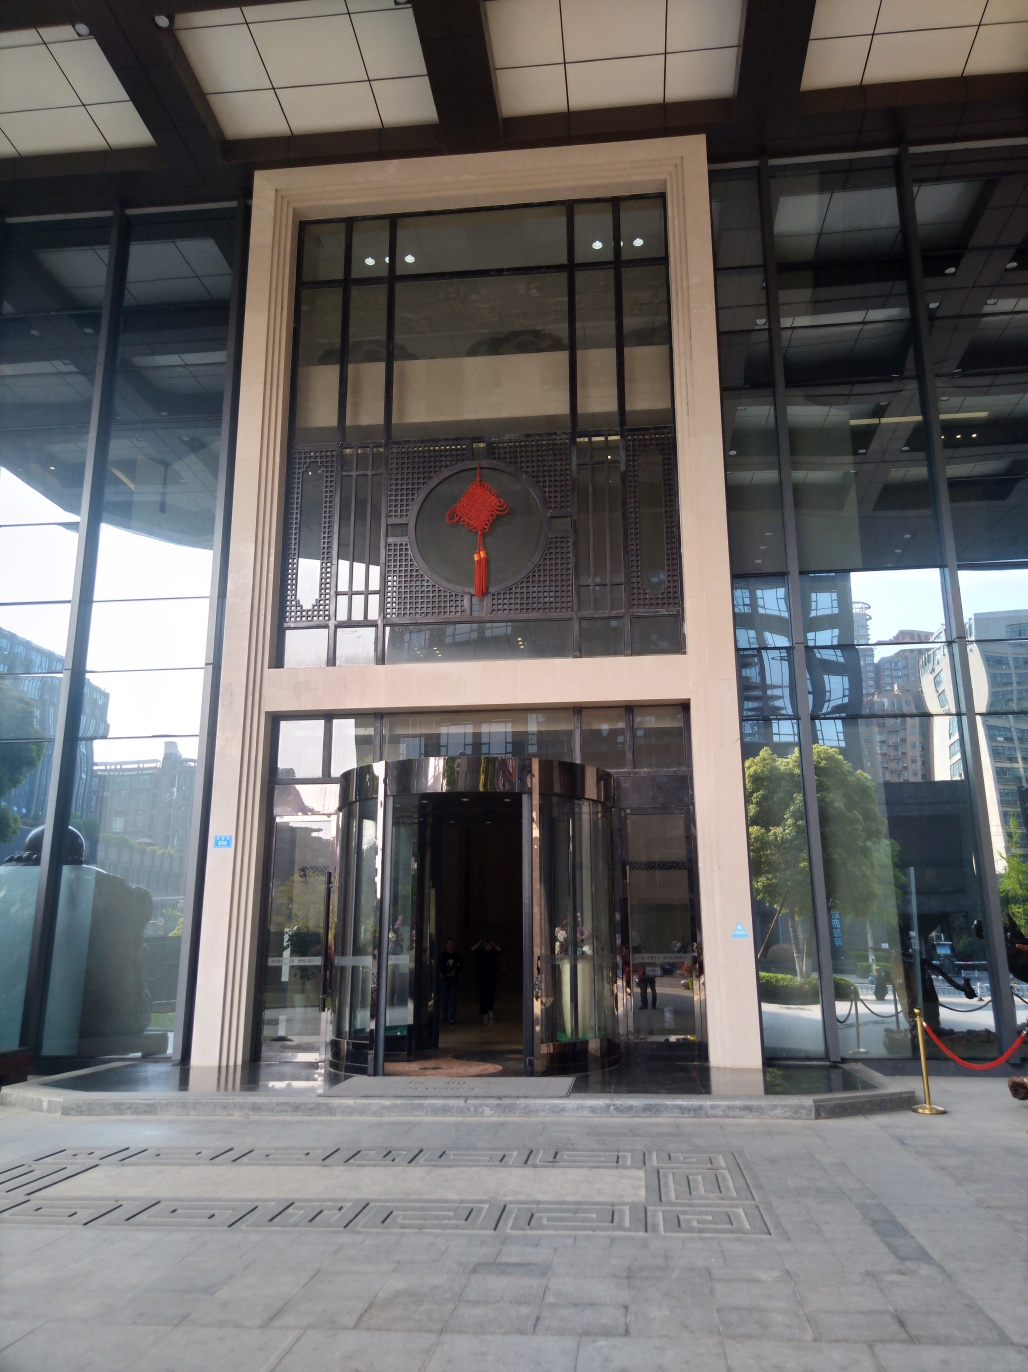Are there any quality issues with this image? The image appears to be slightly tilted, which impacts the symmetry of the architectural elements, and there's a notable glare reflecting on the glass surfaces. Additionally, the lower part of the image is underexposed, making the details less visible. 